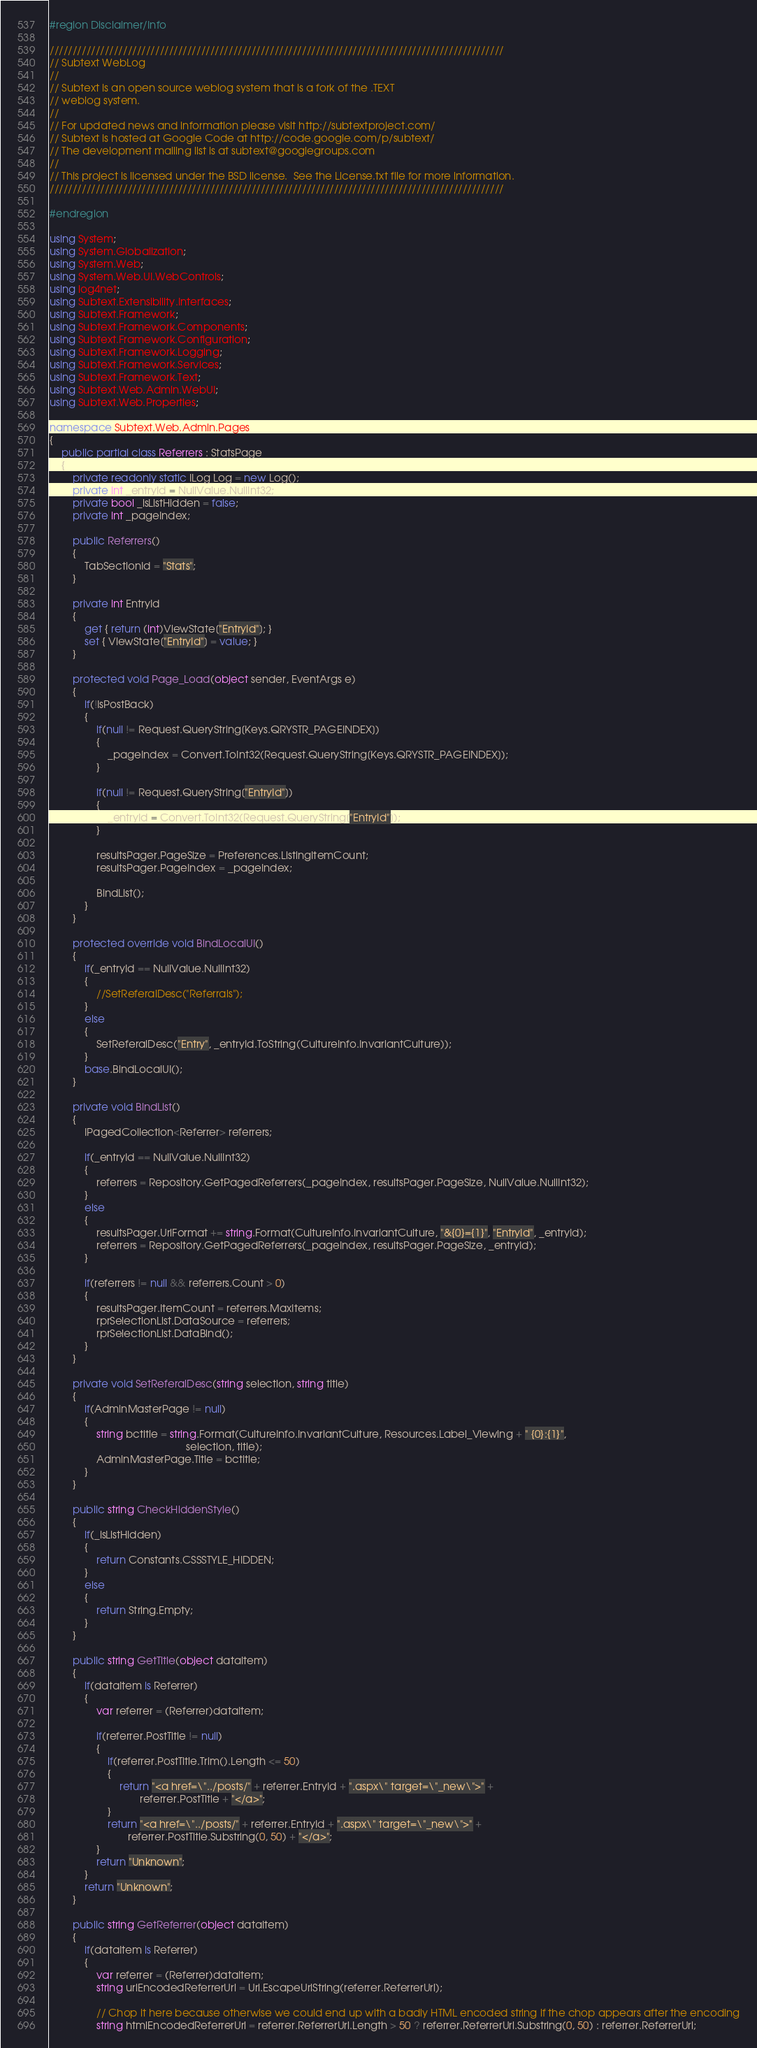Convert code to text. <code><loc_0><loc_0><loc_500><loc_500><_C#_>#region Disclaimer/Info

///////////////////////////////////////////////////////////////////////////////////////////////////
// Subtext WebLog
// 
// Subtext is an open source weblog system that is a fork of the .TEXT
// weblog system.
//
// For updated news and information please visit http://subtextproject.com/
// Subtext is hosted at Google Code at http://code.google.com/p/subtext/
// The development mailing list is at subtext@googlegroups.com 
//
// This project is licensed under the BSD license.  See the License.txt file for more information.
///////////////////////////////////////////////////////////////////////////////////////////////////

#endregion

using System;
using System.Globalization;
using System.Web;
using System.Web.UI.WebControls;
using log4net;
using Subtext.Extensibility.Interfaces;
using Subtext.Framework;
using Subtext.Framework.Components;
using Subtext.Framework.Configuration;
using Subtext.Framework.Logging;
using Subtext.Framework.Services;
using Subtext.Framework.Text;
using Subtext.Web.Admin.WebUI;
using Subtext.Web.Properties;

namespace Subtext.Web.Admin.Pages
{
    public partial class Referrers : StatsPage
    {
        private readonly static ILog Log = new Log();
        private int _entryId = NullValue.NullInt32;
        private bool _isListHidden = false;
        private int _pageIndex;

        public Referrers()
        {
            TabSectionId = "Stats";
        }

        private int EntryId
        {
            get { return (int)ViewState["EntryId"]; }
            set { ViewState["EntryId"] = value; }
        }

        protected void Page_Load(object sender, EventArgs e)
        {
            if(!IsPostBack)
            {
                if(null != Request.QueryString[Keys.QRYSTR_PAGEINDEX])
                {
                    _pageIndex = Convert.ToInt32(Request.QueryString[Keys.QRYSTR_PAGEINDEX]);
                }

                if(null != Request.QueryString["EntryId"])
                {
                    _entryId = Convert.ToInt32(Request.QueryString["EntryId"]);
                }

                resultsPager.PageSize = Preferences.ListingItemCount;
                resultsPager.PageIndex = _pageIndex;

                BindList();
            }
        }

        protected override void BindLocalUI()
        {
            if(_entryId == NullValue.NullInt32)
            {
                //SetReferalDesc("Referrals");
            }
            else
            {
                SetReferalDesc("Entry", _entryId.ToString(CultureInfo.InvariantCulture));
            }
            base.BindLocalUI();
        }

        private void BindList()
        {
            IPagedCollection<Referrer> referrers;

            if(_entryId == NullValue.NullInt32)
            {
                referrers = Repository.GetPagedReferrers(_pageIndex, resultsPager.PageSize, NullValue.NullInt32);
            }
            else
            {
                resultsPager.UrlFormat += string.Format(CultureInfo.InvariantCulture, "&{0}={1}", "EntryId", _entryId);
                referrers = Repository.GetPagedReferrers(_pageIndex, resultsPager.PageSize, _entryId);
            }

            if(referrers != null && referrers.Count > 0)
            {
                resultsPager.ItemCount = referrers.MaxItems;
                rprSelectionList.DataSource = referrers;
                rprSelectionList.DataBind();
            }
        }

        private void SetReferalDesc(string selection, string title)
        {
            if(AdminMasterPage != null)
            {
                string bctitle = string.Format(CultureInfo.InvariantCulture, Resources.Label_Viewing + " {0}:{1}",
                                               selection, title);
                AdminMasterPage.Title = bctitle;
            }
        }

        public string CheckHiddenStyle()
        {
            if(_isListHidden)
            {
                return Constants.CSSSTYLE_HIDDEN;
            }
            else
            {
                return String.Empty;
            }
        }

        public string GetTitle(object dataItem)
        {
            if(dataItem is Referrer)
            {
                var referrer = (Referrer)dataItem;

                if(referrer.PostTitle != null)
                {
                    if(referrer.PostTitle.Trim().Length <= 50)
                    {
                        return "<a href=\"../posts/" + referrer.EntryId + ".aspx\" target=\"_new\">" +
                               referrer.PostTitle + "</a>";
                    }
                    return "<a href=\"../posts/" + referrer.EntryId + ".aspx\" target=\"_new\">" +
                           referrer.PostTitle.Substring(0, 50) + "</a>";
                }
                return "Unknown";
            }
            return "Unknown";
        }

        public string GetReferrer(object dataItem)
        {
            if(dataItem is Referrer)
            {
                var referrer = (Referrer)dataItem;
                string urlEncodedReferrerUrl = Uri.EscapeUriString(referrer.ReferrerUrl);

                // Chop it here because otherwise we could end up with a badly HTML encoded string if the chop appears after the encoding
                string htmlEncodedReferrerUrl = referrer.ReferrerUrl.Length > 50 ? referrer.ReferrerUrl.Substring(0, 50) : referrer.ReferrerUrl;
</code> 